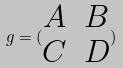Convert formula to latex. <formula><loc_0><loc_0><loc_500><loc_500>g = ( \begin{matrix} A & B \\ C & D \end{matrix} )</formula> 